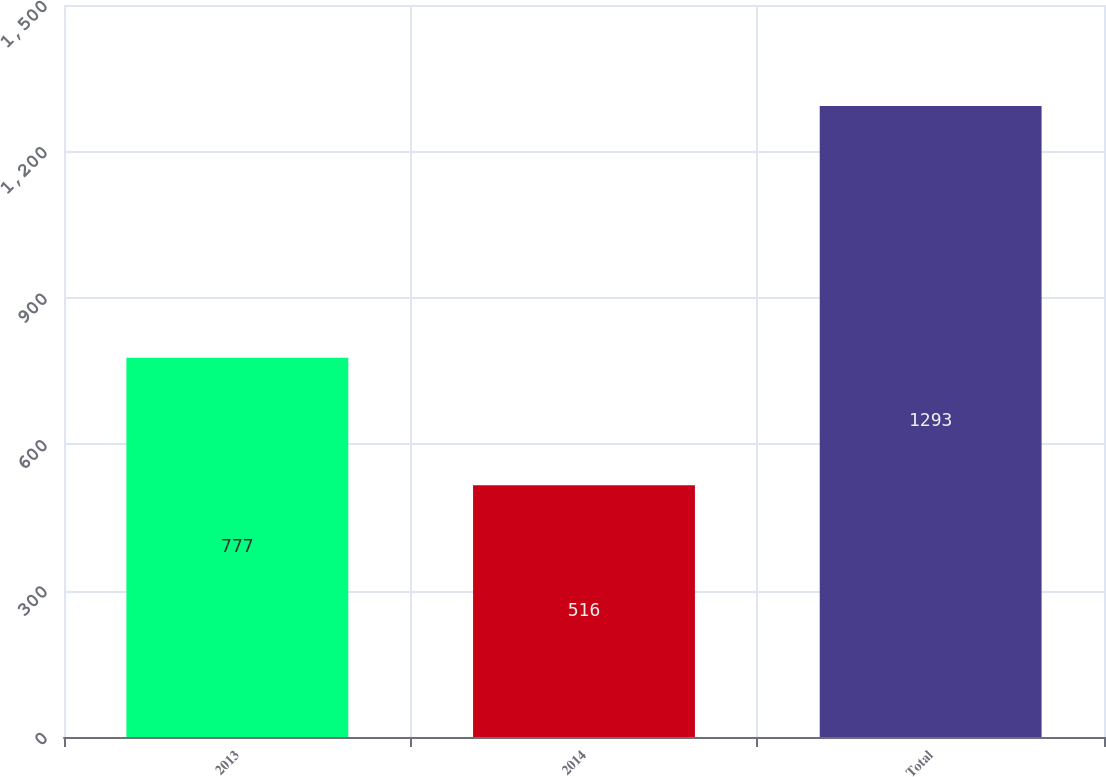Convert chart. <chart><loc_0><loc_0><loc_500><loc_500><bar_chart><fcel>2013<fcel>2014<fcel>Total<nl><fcel>777<fcel>516<fcel>1293<nl></chart> 